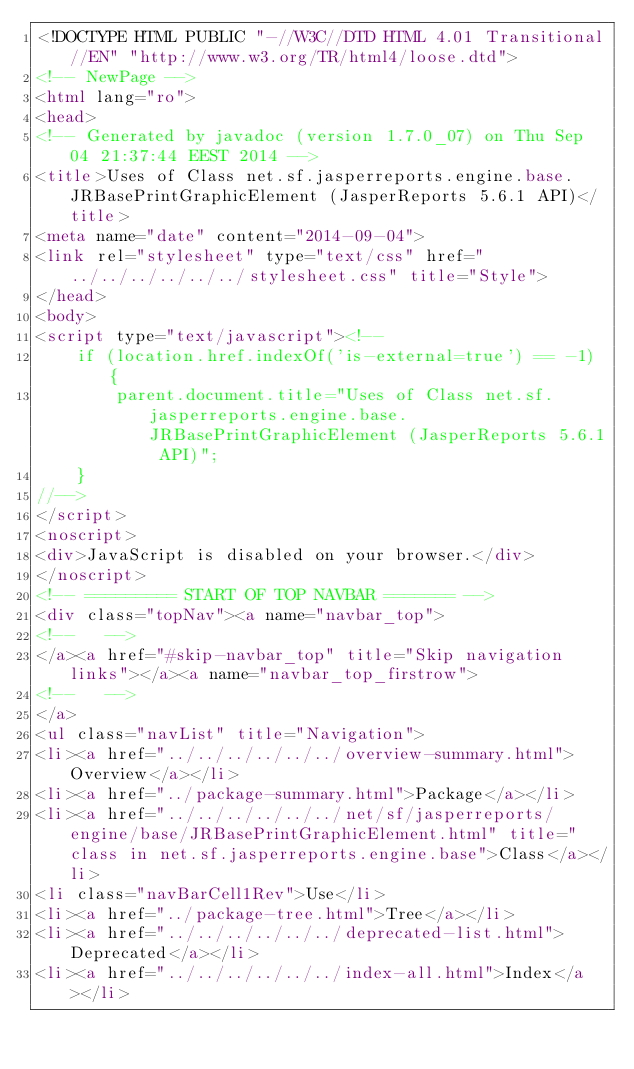<code> <loc_0><loc_0><loc_500><loc_500><_HTML_><!DOCTYPE HTML PUBLIC "-//W3C//DTD HTML 4.01 Transitional//EN" "http://www.w3.org/TR/html4/loose.dtd">
<!-- NewPage -->
<html lang="ro">
<head>
<!-- Generated by javadoc (version 1.7.0_07) on Thu Sep 04 21:37:44 EEST 2014 -->
<title>Uses of Class net.sf.jasperreports.engine.base.JRBasePrintGraphicElement (JasperReports 5.6.1 API)</title>
<meta name="date" content="2014-09-04">
<link rel="stylesheet" type="text/css" href="../../../../../../stylesheet.css" title="Style">
</head>
<body>
<script type="text/javascript"><!--
    if (location.href.indexOf('is-external=true') == -1) {
        parent.document.title="Uses of Class net.sf.jasperreports.engine.base.JRBasePrintGraphicElement (JasperReports 5.6.1 API)";
    }
//-->
</script>
<noscript>
<div>JavaScript is disabled on your browser.</div>
</noscript>
<!-- ========= START OF TOP NAVBAR ======= -->
<div class="topNav"><a name="navbar_top">
<!--   -->
</a><a href="#skip-navbar_top" title="Skip navigation links"></a><a name="navbar_top_firstrow">
<!--   -->
</a>
<ul class="navList" title="Navigation">
<li><a href="../../../../../../overview-summary.html">Overview</a></li>
<li><a href="../package-summary.html">Package</a></li>
<li><a href="../../../../../../net/sf/jasperreports/engine/base/JRBasePrintGraphicElement.html" title="class in net.sf.jasperreports.engine.base">Class</a></li>
<li class="navBarCell1Rev">Use</li>
<li><a href="../package-tree.html">Tree</a></li>
<li><a href="../../../../../../deprecated-list.html">Deprecated</a></li>
<li><a href="../../../../../../index-all.html">Index</a></li></code> 